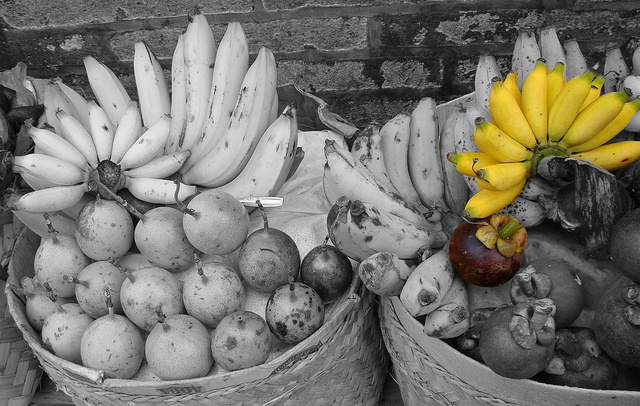Describe the objects in this image and their specific colors. I can see banana in gray, lightgray, darkgray, and black tones, banana in gray, darkgray, black, and lightgray tones, banana in gray, lightgray, darkgray, and black tones, banana in gray, gold, and olive tones, and banana in gray, darkgray, and black tones in this image. 